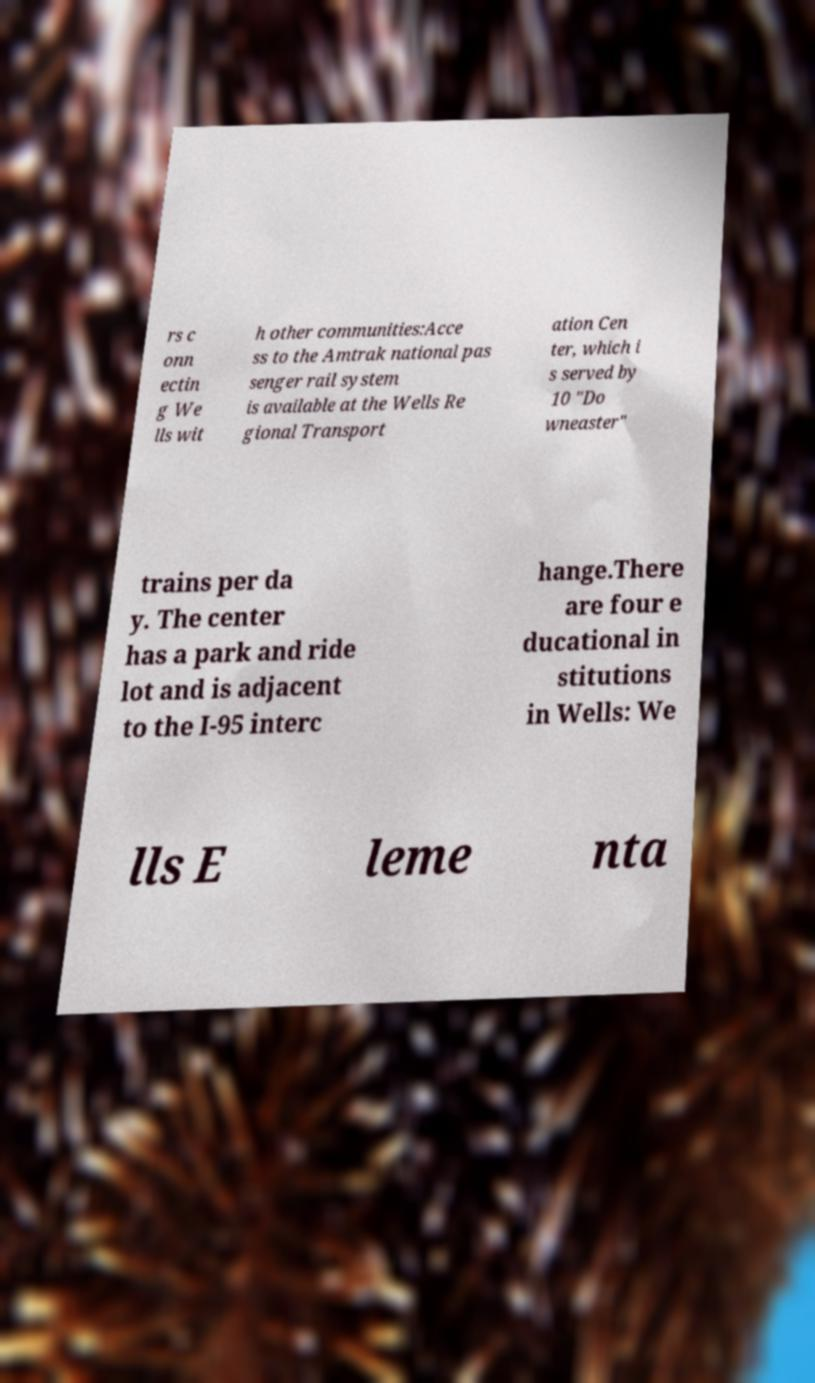For documentation purposes, I need the text within this image transcribed. Could you provide that? rs c onn ectin g We lls wit h other communities:Acce ss to the Amtrak national pas senger rail system is available at the Wells Re gional Transport ation Cen ter, which i s served by 10 "Do wneaster" trains per da y. The center has a park and ride lot and is adjacent to the I-95 interc hange.There are four e ducational in stitutions in Wells: We lls E leme nta 